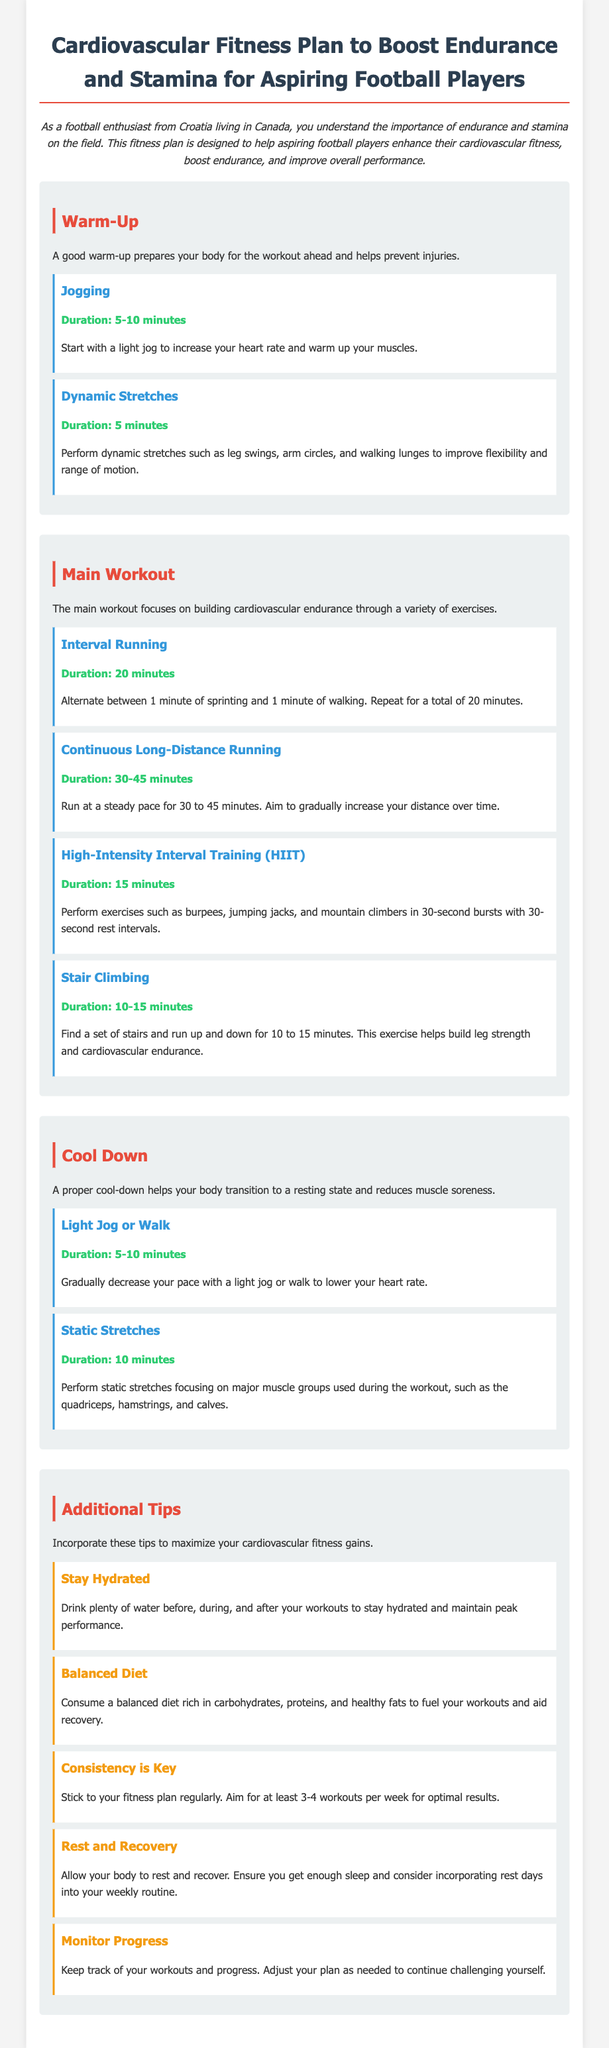What is the title of the document? The title of the document is stated in the heading at the top of the rendered document.
Answer: Cardiovascular Fitness Plan to Boost Endurance and Stamina for Aspiring Football Players What is the duration of interval running? The document specifies the duration for interval running in the main workout section.
Answer: 20 minutes How many minutes should you spend on dynamic stretches? The document lists the duration for dynamic stretches within the warm-up section.
Answer: 5 minutes What type of training does HIIT stand for? The document mentions HIIT in the context of the main workout but does not elaborate in detail.
Answer: High-Intensity Interval Training What is one of the additional tips for maximizing fitness gains? The additional tips section offers several pieces of advice for fitness.
Answer: Stay Hydrated What should you do during the cool-down phase? The cool-down phase is described with specific activities to help the body transition.
Answer: Light Jog or Walk What is the main focus of the workout plan? The document explains the primary purpose and objective of the fitness plan.
Answer: Building cardiovascular endurance How often should you aim to work out for optimal results? The document refers to the recommended frequency of workouts for effectiveness.
Answer: At least 3-4 workouts per week What exercise helps build leg strength and cardiovascular endurance? The main workout section describes a specific exercise for strength and endurance.
Answer: Stair Climbing 